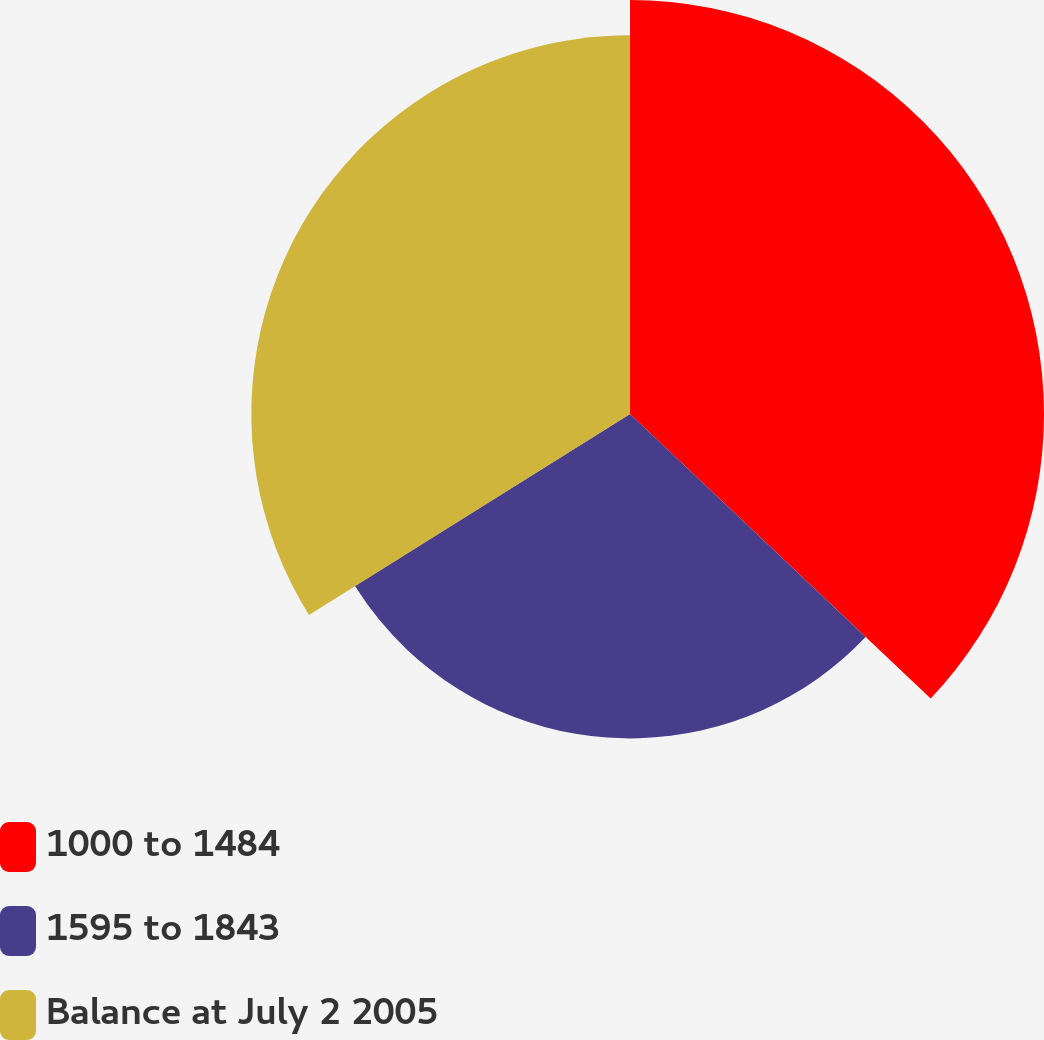<chart> <loc_0><loc_0><loc_500><loc_500><pie_chart><fcel>1000 to 1484<fcel>1595 to 1843<fcel>Balance at July 2 2005<nl><fcel>37.06%<fcel>29.04%<fcel>33.9%<nl></chart> 